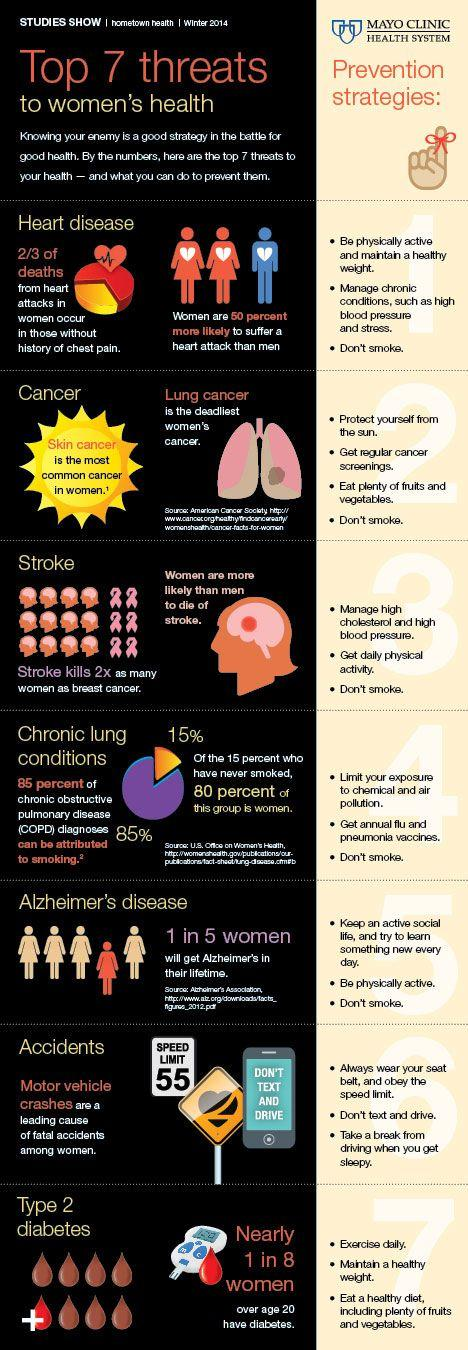Draw attention to some important aspects in this diagram. Two serious diseases, cancer and Type 2 diabetes, are primarily caused by an unhealthy diet. Smoking is the common cause of five diseases among the seven threats listed, which are drinking, smoking, or physical inactivity. 